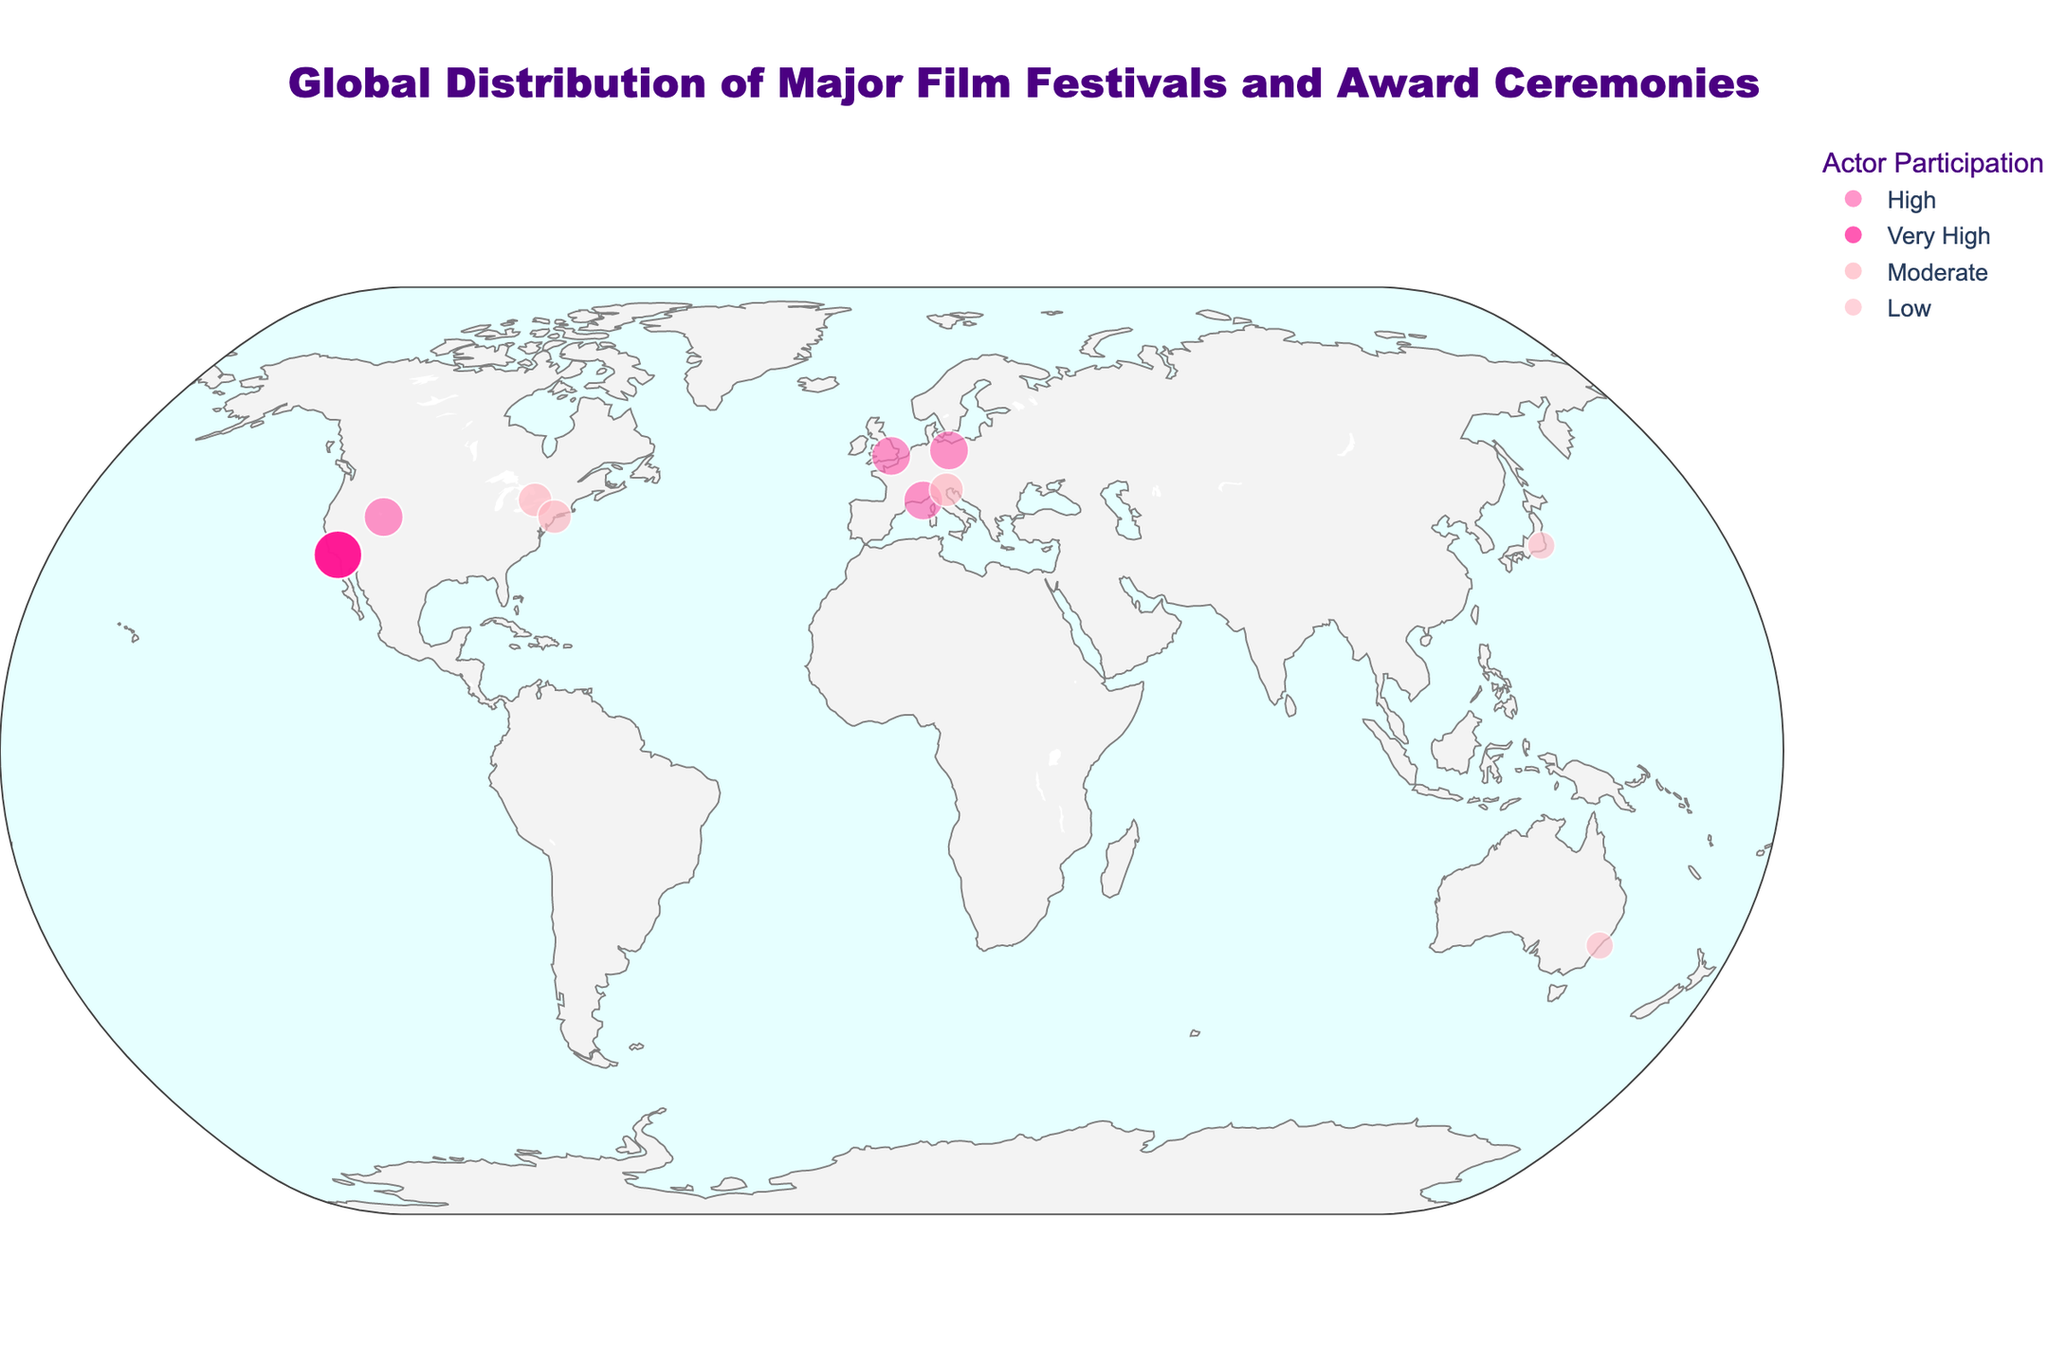Which city hosts the Berlin International Film Festival? We can look at the geographic plot and find the Berlin International Film Festival, which is marked on the plot.
Answer: Berlin How many major film festivals and award ceremonies are marked in the United States? On the plot, identify all points within the United States boundaries. Count each one marked with a corresponding name.
Answer: Four In which continent are most of these major film festivals and award ceremonies located? By observing the plot and grouping the locations by continent, Europe appears with the highest density of points.
Answer: Europe What is the only major film festival with 'Very High' actor participation outside the USA? By analyzing the colors and legend of actor participation, find any 'Very High' participations outside the USA. The Cannes Film Festival in France is marked with this level.
Answer: Cannes Film Festival Comparing the Berlin and Venice Film Festivals, which one has a higher level of actor participation? By examining the color of points for both Berlin and Venice on the plot according to the legend, Berlin is 'High' while Venice is 'Moderate'.
Answer: Berlin What is the coordinate (latitude and longitude) of the Sydney Film Festival? Look at the plot to identify the Sydney Film Festival point and note its hover information for coordinates.
Answer: (-33.8688, 151.2093) How many film festivals or award ceremonies categorize actor participation as 'Low'? Identifying the points colored corresponding to 'Low' actor participation according to the legend and counting them gives us three points.
Answer: Two Which city in Japan hosts a recognized film festival? Find the point representing Japan on the plot and identify its city and name from the hover information.
Answer: Tokyo Among the listed film festivals and award ceremonies, which event located in the USA ranks 'High' in actor participation? By examining the points specifically within the USA and the colors indicating 'High' participation according to the legend, the Sundance Film Festival in Park City fits this criterion.
Answer: Sundance Film Festival What is the range of latitudes for all the major film festivals and award ceremonies displayed on the plot? Identify the northernmost and southernmost points on the plot to determine the range. Berlin, Germany is the northernmost, and Sydney, Australia is the southernmost, so the range is from -33.8688 to 52.5200.
Answer: From -33.8688 to 52.5200 